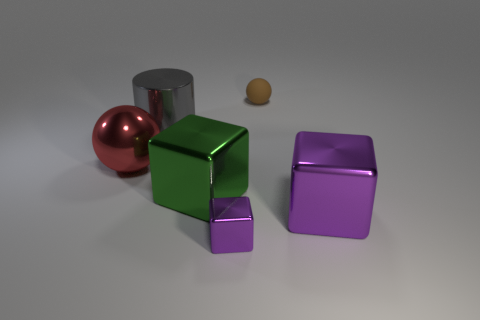What might be the relative sizes of these objects, and how can we tell? The relative sizes of the objects seem to vary, with the spheres appearing smaller than the cubes. Perspective and the placement of the objects suggest a variation in size, and their proportions in relation to each other give clues about their actual size, with the largest object being the green cube in the foreground. 